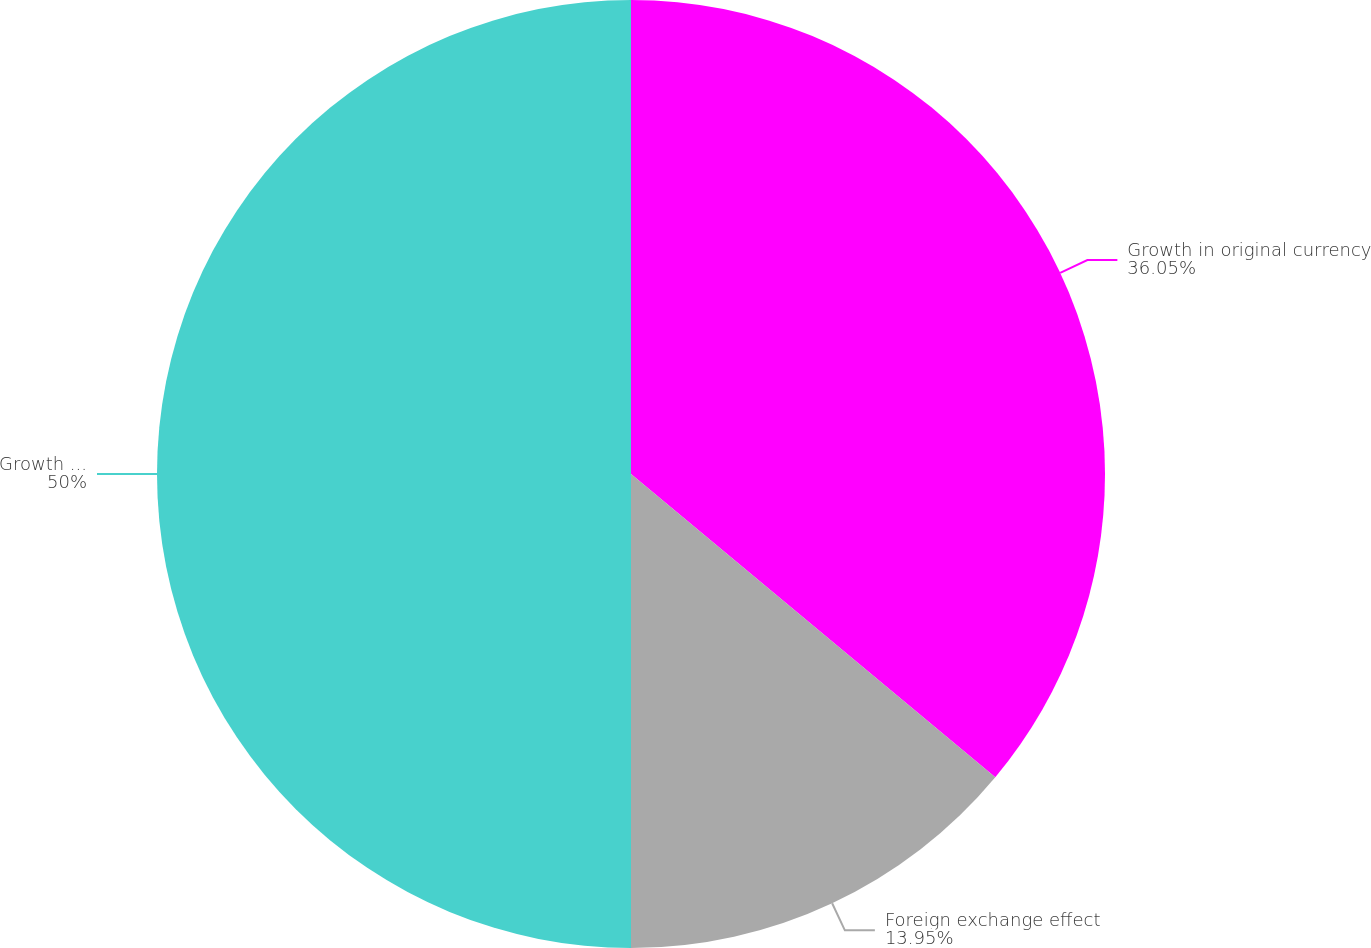Convert chart. <chart><loc_0><loc_0><loc_500><loc_500><pie_chart><fcel>Growth in original currency<fcel>Foreign exchange effect<fcel>Growth as reported in US<nl><fcel>36.05%<fcel>13.95%<fcel>50.0%<nl></chart> 